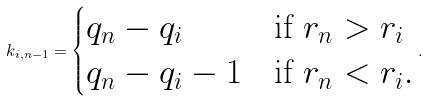Convert formula to latex. <formula><loc_0><loc_0><loc_500><loc_500>k _ { i , n - 1 } = \begin{cases} q _ { n } - q _ { i } & \text {if } r _ { n } > r _ { i } \\ q _ { n } - q _ { i } - 1 & \text {if } r _ { n } < r _ { i } . \end{cases} .</formula> 